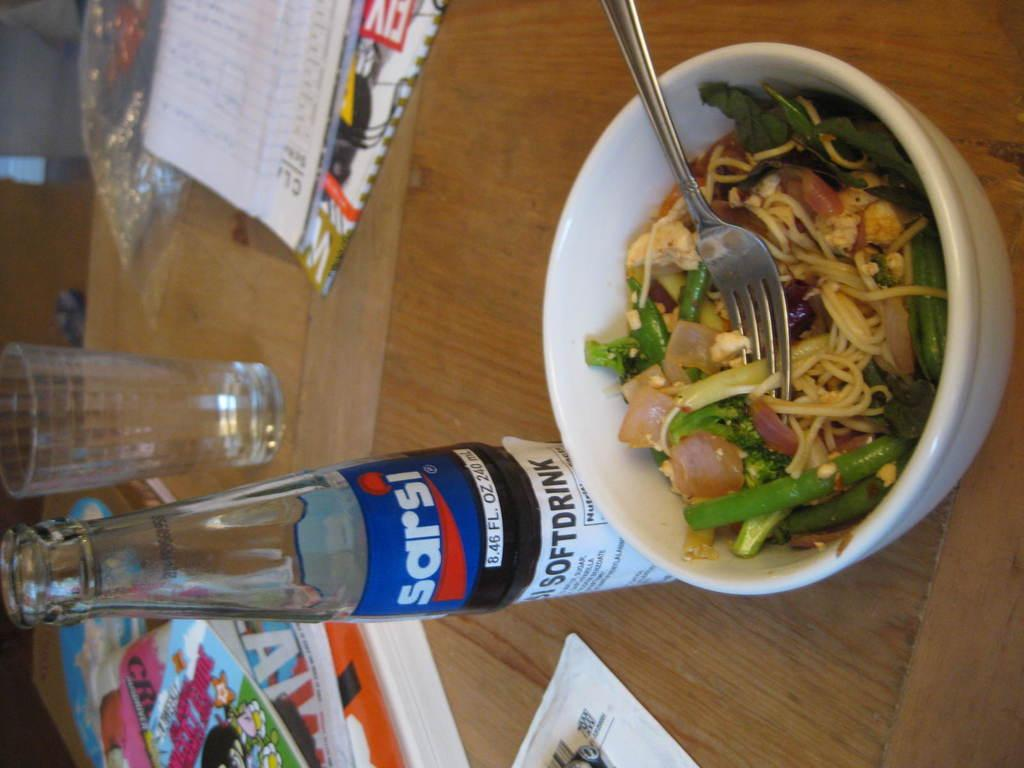<image>
Create a compact narrative representing the image presented. A bottle place on a table, it is from the brand Sarsi. 